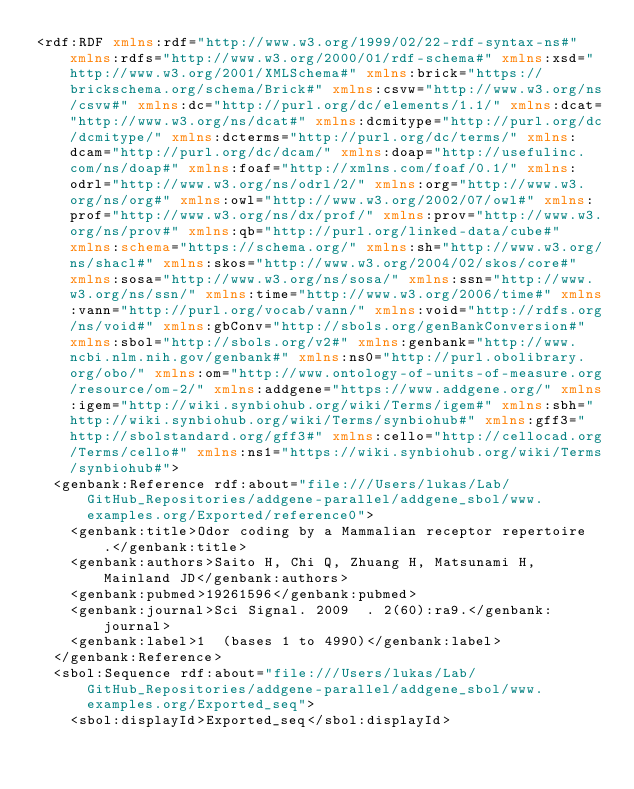Convert code to text. <code><loc_0><loc_0><loc_500><loc_500><_XML_><rdf:RDF xmlns:rdf="http://www.w3.org/1999/02/22-rdf-syntax-ns#" xmlns:rdfs="http://www.w3.org/2000/01/rdf-schema#" xmlns:xsd="http://www.w3.org/2001/XMLSchema#" xmlns:brick="https://brickschema.org/schema/Brick#" xmlns:csvw="http://www.w3.org/ns/csvw#" xmlns:dc="http://purl.org/dc/elements/1.1/" xmlns:dcat="http://www.w3.org/ns/dcat#" xmlns:dcmitype="http://purl.org/dc/dcmitype/" xmlns:dcterms="http://purl.org/dc/terms/" xmlns:dcam="http://purl.org/dc/dcam/" xmlns:doap="http://usefulinc.com/ns/doap#" xmlns:foaf="http://xmlns.com/foaf/0.1/" xmlns:odrl="http://www.w3.org/ns/odrl/2/" xmlns:org="http://www.w3.org/ns/org#" xmlns:owl="http://www.w3.org/2002/07/owl#" xmlns:prof="http://www.w3.org/ns/dx/prof/" xmlns:prov="http://www.w3.org/ns/prov#" xmlns:qb="http://purl.org/linked-data/cube#" xmlns:schema="https://schema.org/" xmlns:sh="http://www.w3.org/ns/shacl#" xmlns:skos="http://www.w3.org/2004/02/skos/core#" xmlns:sosa="http://www.w3.org/ns/sosa/" xmlns:ssn="http://www.w3.org/ns/ssn/" xmlns:time="http://www.w3.org/2006/time#" xmlns:vann="http://purl.org/vocab/vann/" xmlns:void="http://rdfs.org/ns/void#" xmlns:gbConv="http://sbols.org/genBankConversion#" xmlns:sbol="http://sbols.org/v2#" xmlns:genbank="http://www.ncbi.nlm.nih.gov/genbank#" xmlns:ns0="http://purl.obolibrary.org/obo/" xmlns:om="http://www.ontology-of-units-of-measure.org/resource/om-2/" xmlns:addgene="https://www.addgene.org/" xmlns:igem="http://wiki.synbiohub.org/wiki/Terms/igem#" xmlns:sbh="http://wiki.synbiohub.org/wiki/Terms/synbiohub#" xmlns:gff3="http://sbolstandard.org/gff3#" xmlns:cello="http://cellocad.org/Terms/cello#" xmlns:ns1="https://wiki.synbiohub.org/wiki/Terms/synbiohub#">
  <genbank:Reference rdf:about="file:///Users/lukas/Lab/GitHub_Repositories/addgene-parallel/addgene_sbol/www.examples.org/Exported/reference0">
    <genbank:title>Odor coding by a Mammalian receptor repertoire.</genbank:title>
    <genbank:authors>Saito H, Chi Q, Zhuang H, Matsunami H, Mainland JD</genbank:authors>
    <genbank:pubmed>19261596</genbank:pubmed>
    <genbank:journal>Sci Signal. 2009  . 2(60):ra9.</genbank:journal>
    <genbank:label>1  (bases 1 to 4990)</genbank:label>
  </genbank:Reference>
  <sbol:Sequence rdf:about="file:///Users/lukas/Lab/GitHub_Repositories/addgene-parallel/addgene_sbol/www.examples.org/Exported_seq">
    <sbol:displayId>Exported_seq</sbol:displayId></code> 